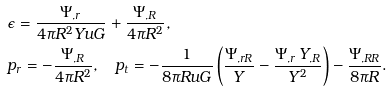Convert formula to latex. <formula><loc_0><loc_0><loc_500><loc_500>& \epsilon = \frac { \Psi _ { , r } } { 4 \pi R ^ { 2 } Y u G } + \frac { \Psi _ { , R } } { 4 \pi R ^ { 2 } } , \\ & p _ { r } = - \frac { \Psi _ { , R } } { 4 \pi R ^ { 2 } } , \quad p _ { t } = - \frac { 1 } { 8 \pi R u G } \left ( \frac { \Psi _ { , r R } } { Y } - \frac { \Psi _ { , r } \, Y _ { , R } } { Y ^ { 2 } } \right ) - \frac { \Psi _ { , R R } } { 8 \pi R } .</formula> 